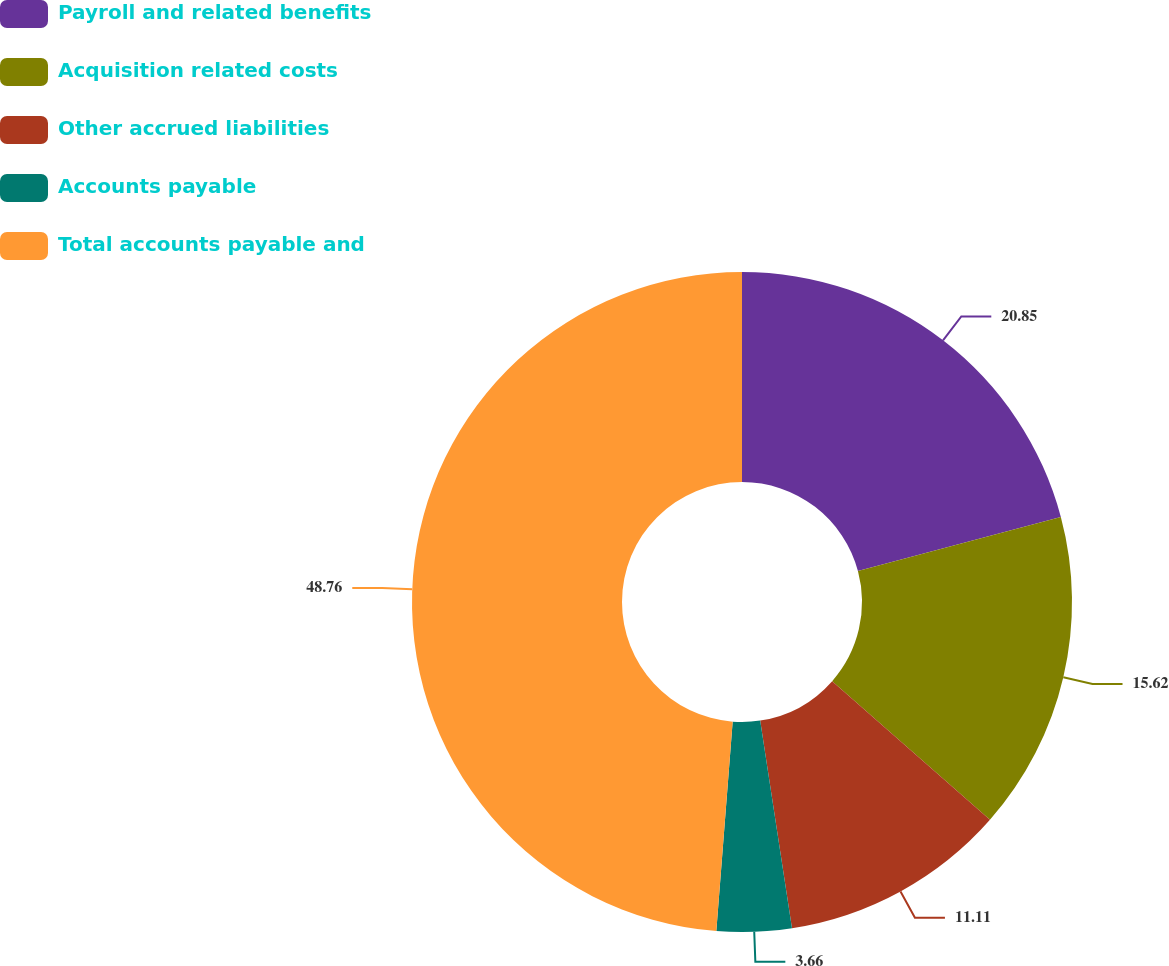Convert chart. <chart><loc_0><loc_0><loc_500><loc_500><pie_chart><fcel>Payroll and related benefits<fcel>Acquisition related costs<fcel>Other accrued liabilities<fcel>Accounts payable<fcel>Total accounts payable and<nl><fcel>20.85%<fcel>15.62%<fcel>11.11%<fcel>3.66%<fcel>48.76%<nl></chart> 